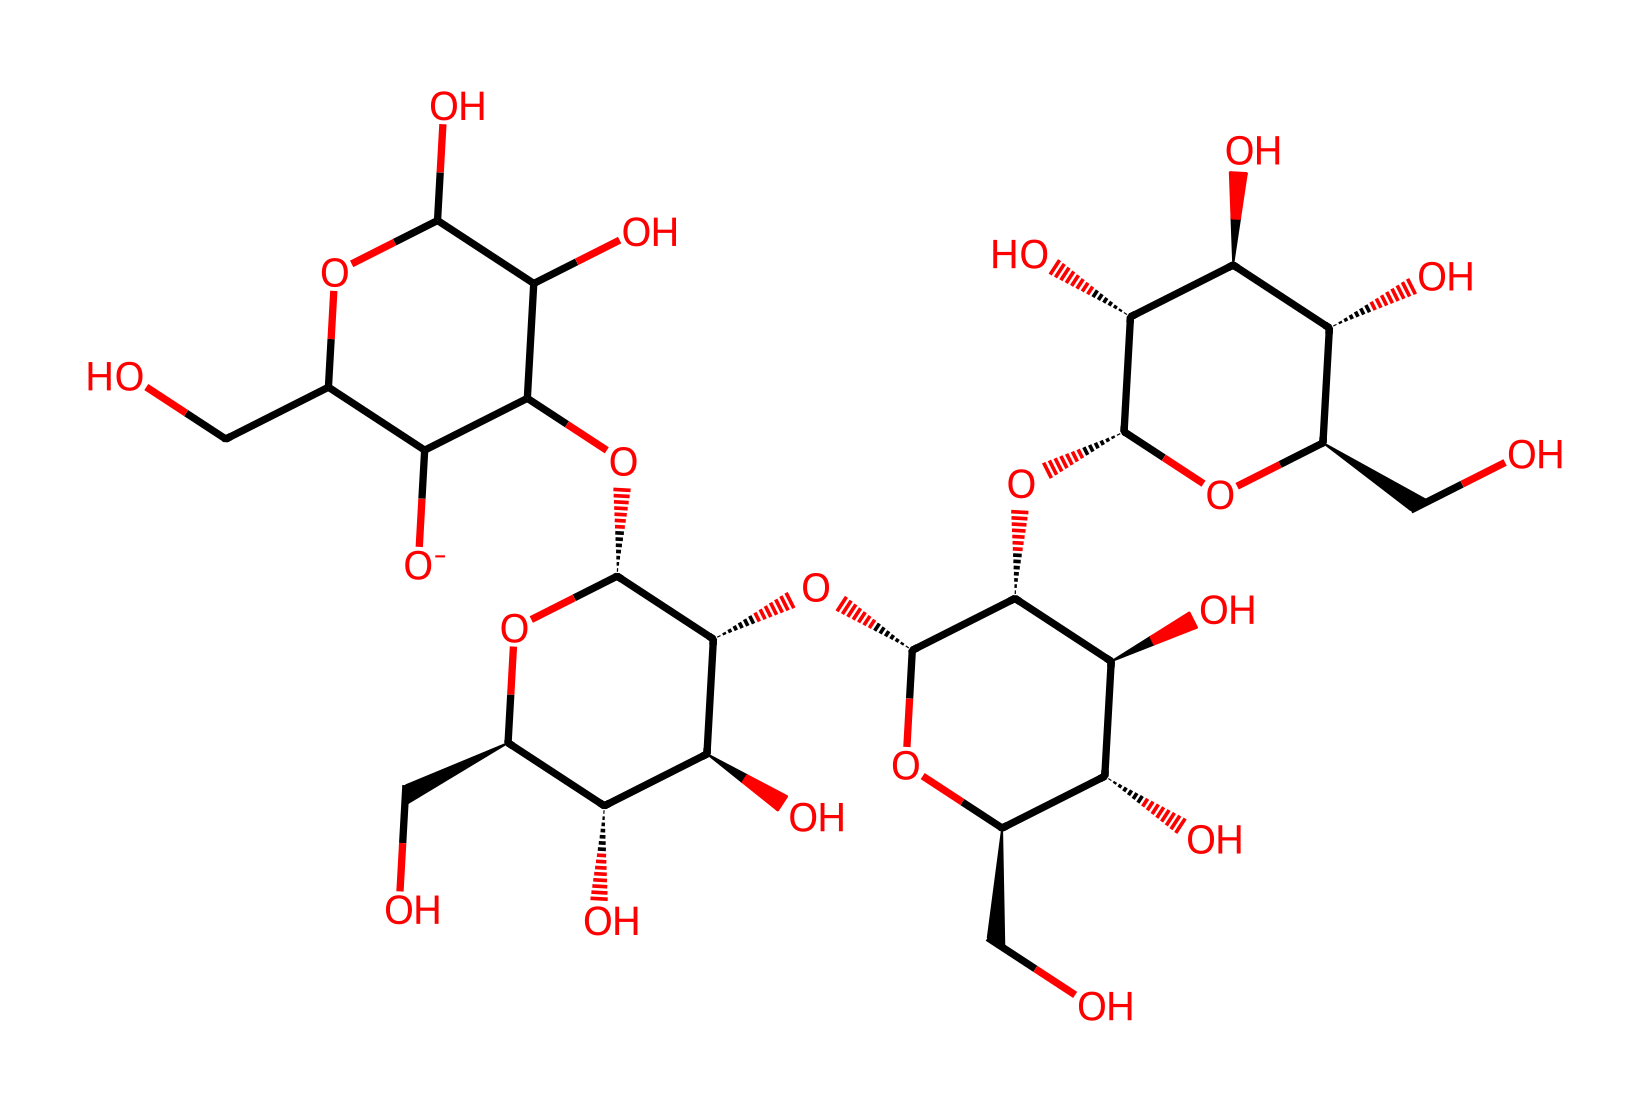What type of molecule is represented by this structure? The chemical displayed is mainly constituted of carbon, hydrogen, and oxygen, indicating it is a type of carbohydrate.
Answer: carbohydrate How many rings are present in the structure? By examining the structure, it can be observed that there are multiple cyclic forms, specifically two five-membered rings and one six-membered ring.
Answer: three What is the predominant functional group in this molecule? The molecule contains numerous alcohol (-OH) groups, which are recognized as the dominant functional group contributing to its properties.
Answer: alcohol Which structural feature is responsible for its Non-Newtonian behavior? The presence of cellulose nanocrystals gives the fluid its unique structural arrangement, which impacts flow characteristics and allows for Non-Newtonian behavior.
Answer: cellulose nanocrystals How many hydroxyl groups are available in this molecule? Counting the -OH groups present in the structure reveals there are nine hydroxyl groups contributing to the overall properties.
Answer: nine What property of this chemical facilitates eco-friendliness? The renewable nature of cellulose, derived from plants, coupled with its biodegradable properties, signifies its eco-friendliness when used in production.
Answer: biodegradable 